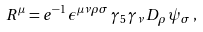<formula> <loc_0><loc_0><loc_500><loc_500>R ^ { \mu } = e ^ { - 1 } \, \epsilon ^ { \mu \nu \rho \sigma } \, \gamma _ { 5 } \, \gamma _ { \nu } \, D _ { \rho } \, \psi _ { \sigma } \, ,</formula> 